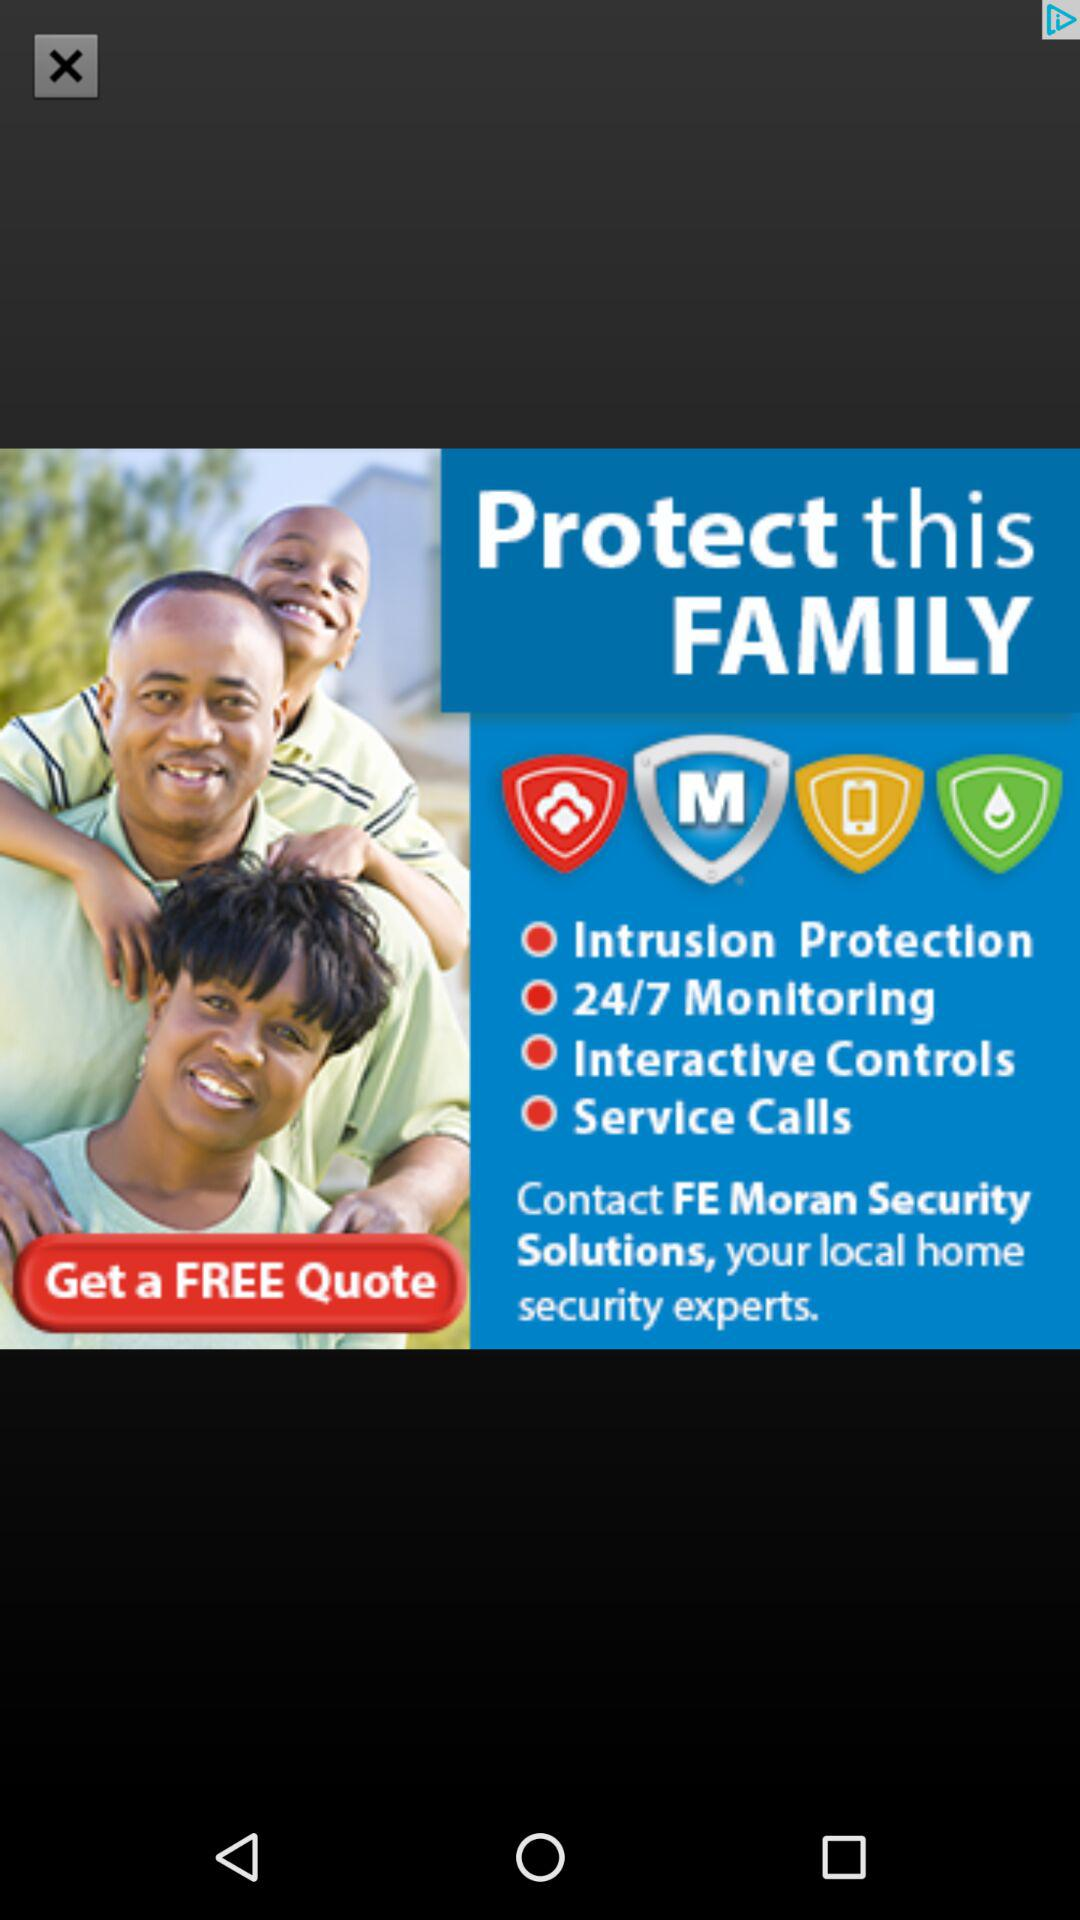How many services are offered by FE Moran Security Solutions?
Answer the question using a single word or phrase. 4 